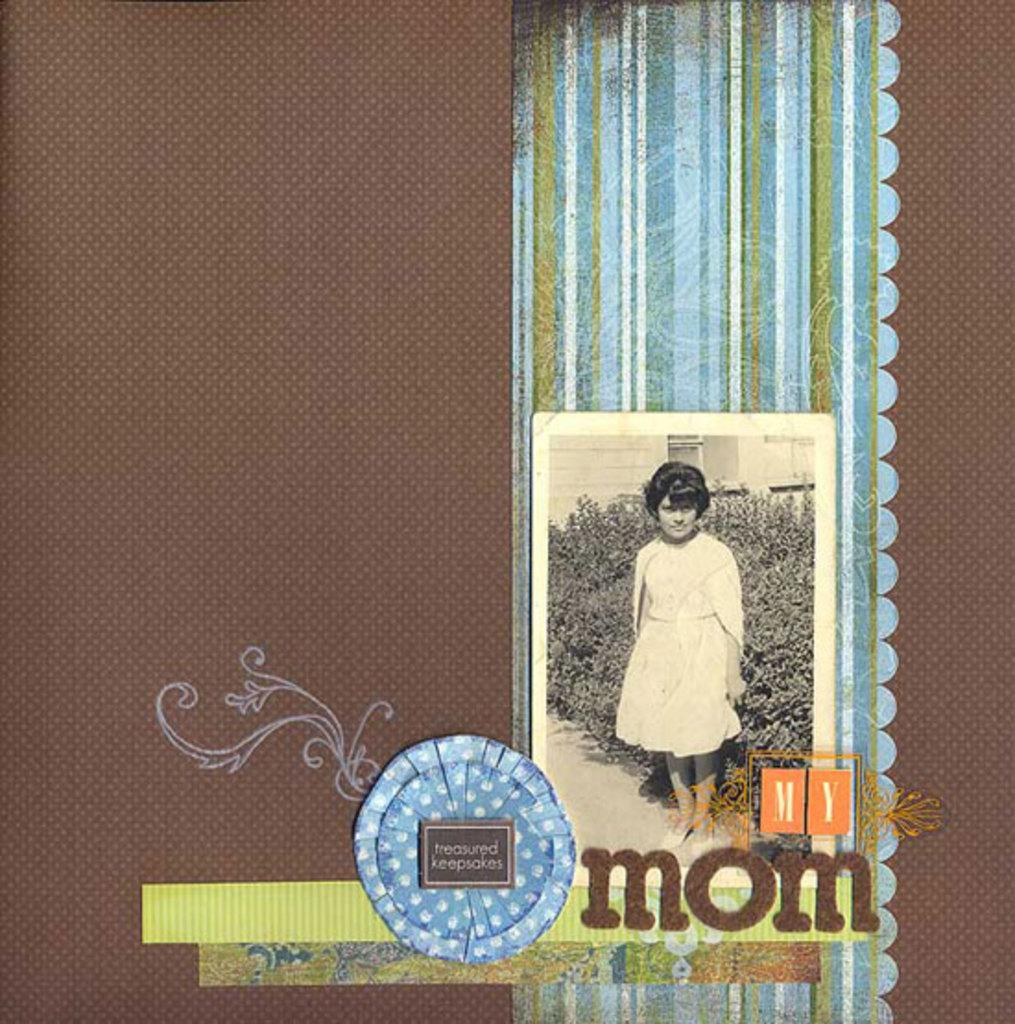What is the color of the object in the image? The object in the image is brown. What is on the brown object? There is a photo on the brown object. What is depicted in the photo? The photo contains an image of a girl. What can be seen behind the girl in the photo? There are plants visible behind the girl in the photo. What is written under the photo? There are words written under the photo. What type of bone is visible in the image? There is no bone visible in the image. What kind of slip is shown on the girl's feet in the photo? There is no information about the girl's feet or any footwear in the image. 